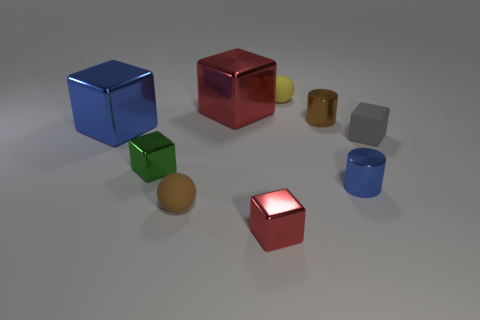There is a blue object that is to the left of the small yellow ball; is its size the same as the metal cylinder that is in front of the brown metal thing?
Offer a very short reply. No. What number of things are either big red metallic blocks or large shiny things that are on the right side of the big blue shiny block?
Offer a terse response. 1. What size is the red shiny thing that is behind the green object?
Your answer should be compact. Large. Is the number of cylinders that are left of the brown metallic thing less than the number of tiny objects that are in front of the large blue object?
Offer a very short reply. Yes. What material is the thing that is on the right side of the yellow rubber ball and behind the big blue cube?
Your answer should be very brief. Metal. There is a small brown object behind the cylinder that is in front of the large blue metallic object; what shape is it?
Offer a terse response. Cylinder. How many yellow things are cubes or cylinders?
Offer a terse response. 0. Are there any brown rubber objects behind the large red shiny object?
Your answer should be compact. No. What is the size of the rubber cube?
Give a very brief answer. Small. There is a blue object that is the same shape as the green thing; what is its size?
Offer a terse response. Large. 